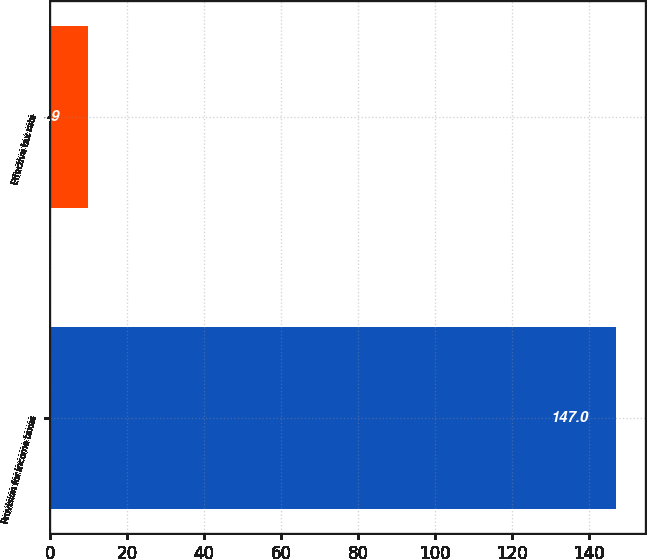<chart> <loc_0><loc_0><loc_500><loc_500><bar_chart><fcel>Provision for income taxes<fcel>Effective tax rate<nl><fcel>147<fcel>9.9<nl></chart> 